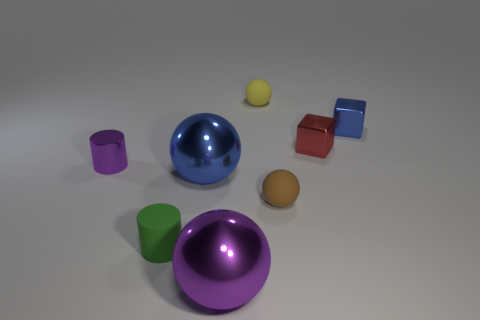Subtract 1 spheres. How many spheres are left? 3 Add 2 purple spheres. How many objects exist? 10 Subtract all cylinders. How many objects are left? 6 Subtract all cyan metallic things. Subtract all large purple metallic objects. How many objects are left? 7 Add 6 purple metallic cylinders. How many purple metallic cylinders are left? 7 Add 6 small green cylinders. How many small green cylinders exist? 7 Subtract 1 blue blocks. How many objects are left? 7 